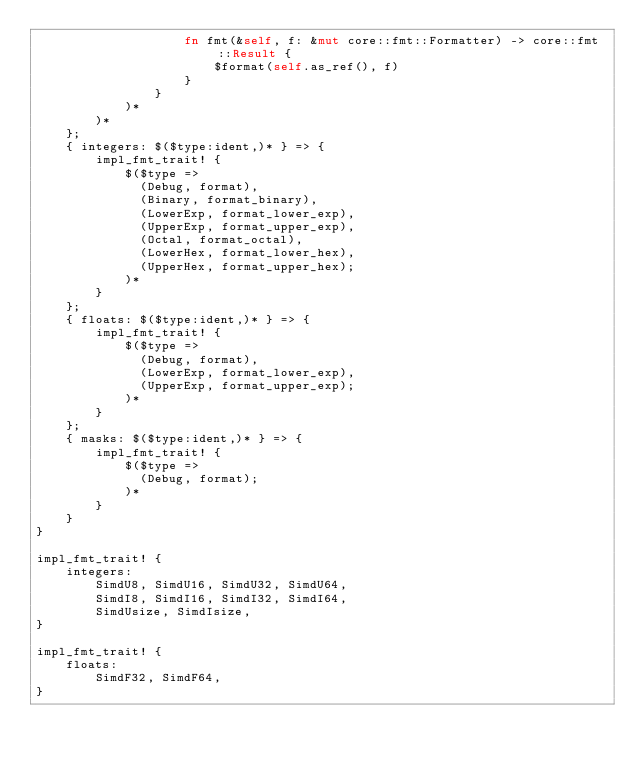Convert code to text. <code><loc_0><loc_0><loc_500><loc_500><_Rust_>                    fn fmt(&self, f: &mut core::fmt::Formatter) -> core::fmt::Result {
                        $format(self.as_ref(), f)
                    }
                }
            )*
        )*
    };
    { integers: $($type:ident,)* } => {
        impl_fmt_trait! {
            $($type =>
              (Debug, format),
              (Binary, format_binary),
              (LowerExp, format_lower_exp),
              (UpperExp, format_upper_exp),
              (Octal, format_octal),
              (LowerHex, format_lower_hex),
              (UpperHex, format_upper_hex);
            )*
        }
    };
    { floats: $($type:ident,)* } => {
        impl_fmt_trait! {
            $($type =>
              (Debug, format),
              (LowerExp, format_lower_exp),
              (UpperExp, format_upper_exp);
            )*
        }
    };
    { masks: $($type:ident,)* } => {
        impl_fmt_trait! {
            $($type =>
              (Debug, format);
            )*
        }
    }
}

impl_fmt_trait! {
    integers:
        SimdU8, SimdU16, SimdU32, SimdU64,
        SimdI8, SimdI16, SimdI32, SimdI64,
        SimdUsize, SimdIsize,
}

impl_fmt_trait! {
    floats:
        SimdF32, SimdF64,
}
</code> 